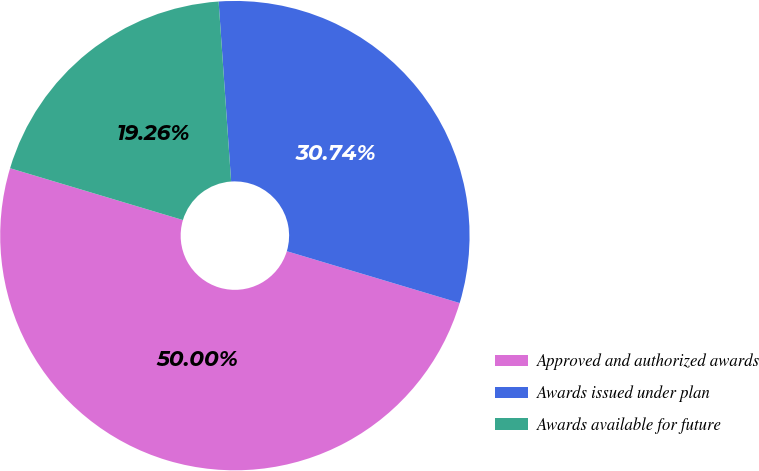<chart> <loc_0><loc_0><loc_500><loc_500><pie_chart><fcel>Approved and authorized awards<fcel>Awards issued under plan<fcel>Awards available for future<nl><fcel>50.0%<fcel>30.74%<fcel>19.26%<nl></chart> 